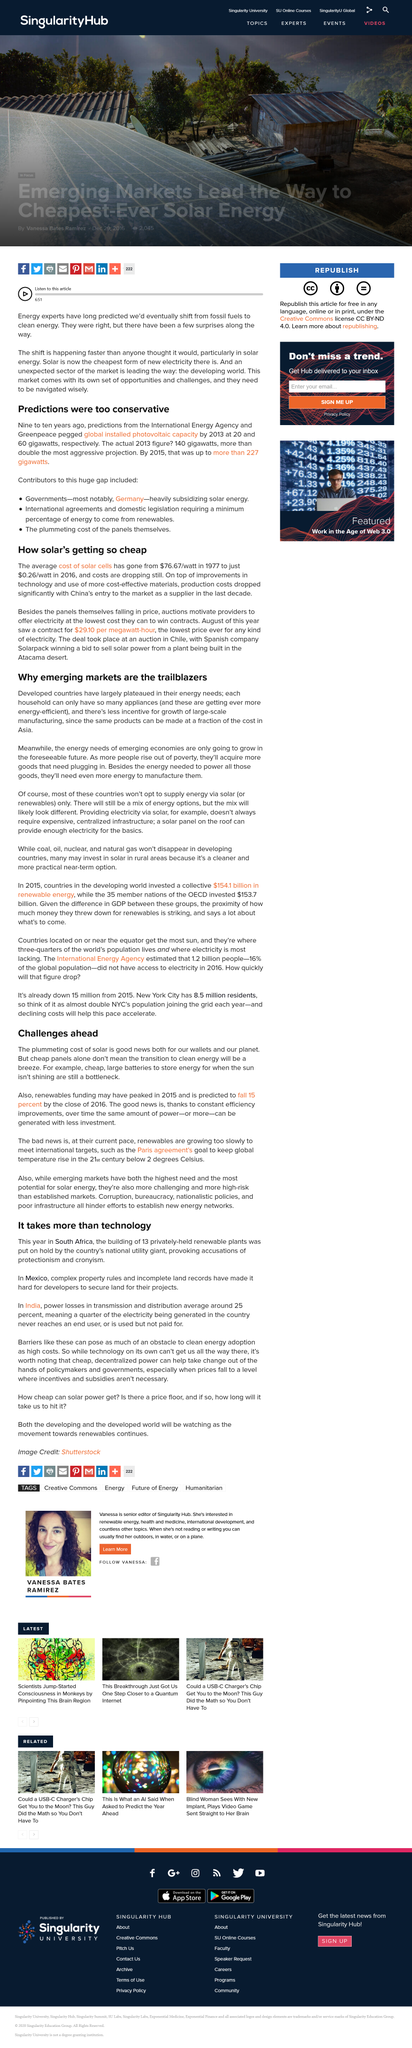Mention a couple of crucial points in this snapshot. In 2016, the average cost of solar cells was approximately $0.26 per watt, making solar power a cost-effective and sustainable source of energy for the future. In 2015, renewables funding may have peaked. Cheap, decentralized power has the potential to take change out of the hands of policymakers and governments by giving individuals and communities the power to generate and control their own energy, thereby reducing dependence on traditional power sources and the influence of policymakers and governments in the energy sector. China is currently in the market as a supplier of solar technology. The International Energy Agency predicted that the global installed photovoltaic capacity would reach 20 gigawatts in 2013. 